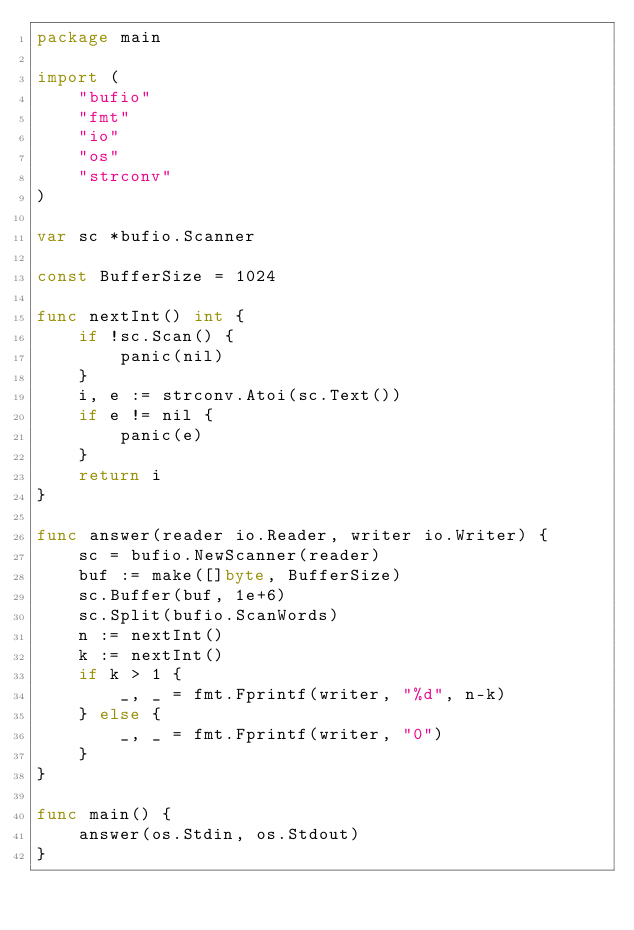Convert code to text. <code><loc_0><loc_0><loc_500><loc_500><_Go_>package main

import (
	"bufio"
	"fmt"
	"io"
	"os"
	"strconv"
)

var sc *bufio.Scanner

const BufferSize = 1024

func nextInt() int {
	if !sc.Scan() {
		panic(nil)
	}
	i, e := strconv.Atoi(sc.Text())
	if e != nil {
		panic(e)
	}
	return i
}

func answer(reader io.Reader, writer io.Writer) {
	sc = bufio.NewScanner(reader)
	buf := make([]byte, BufferSize)
	sc.Buffer(buf, 1e+6)
	sc.Split(bufio.ScanWords)
	n := nextInt()
	k := nextInt()
	if k > 1 {
		_, _ = fmt.Fprintf(writer, "%d", n-k)
	} else {
		_, _ = fmt.Fprintf(writer, "0")
	}
}

func main() {
	answer(os.Stdin, os.Stdout)
}
</code> 